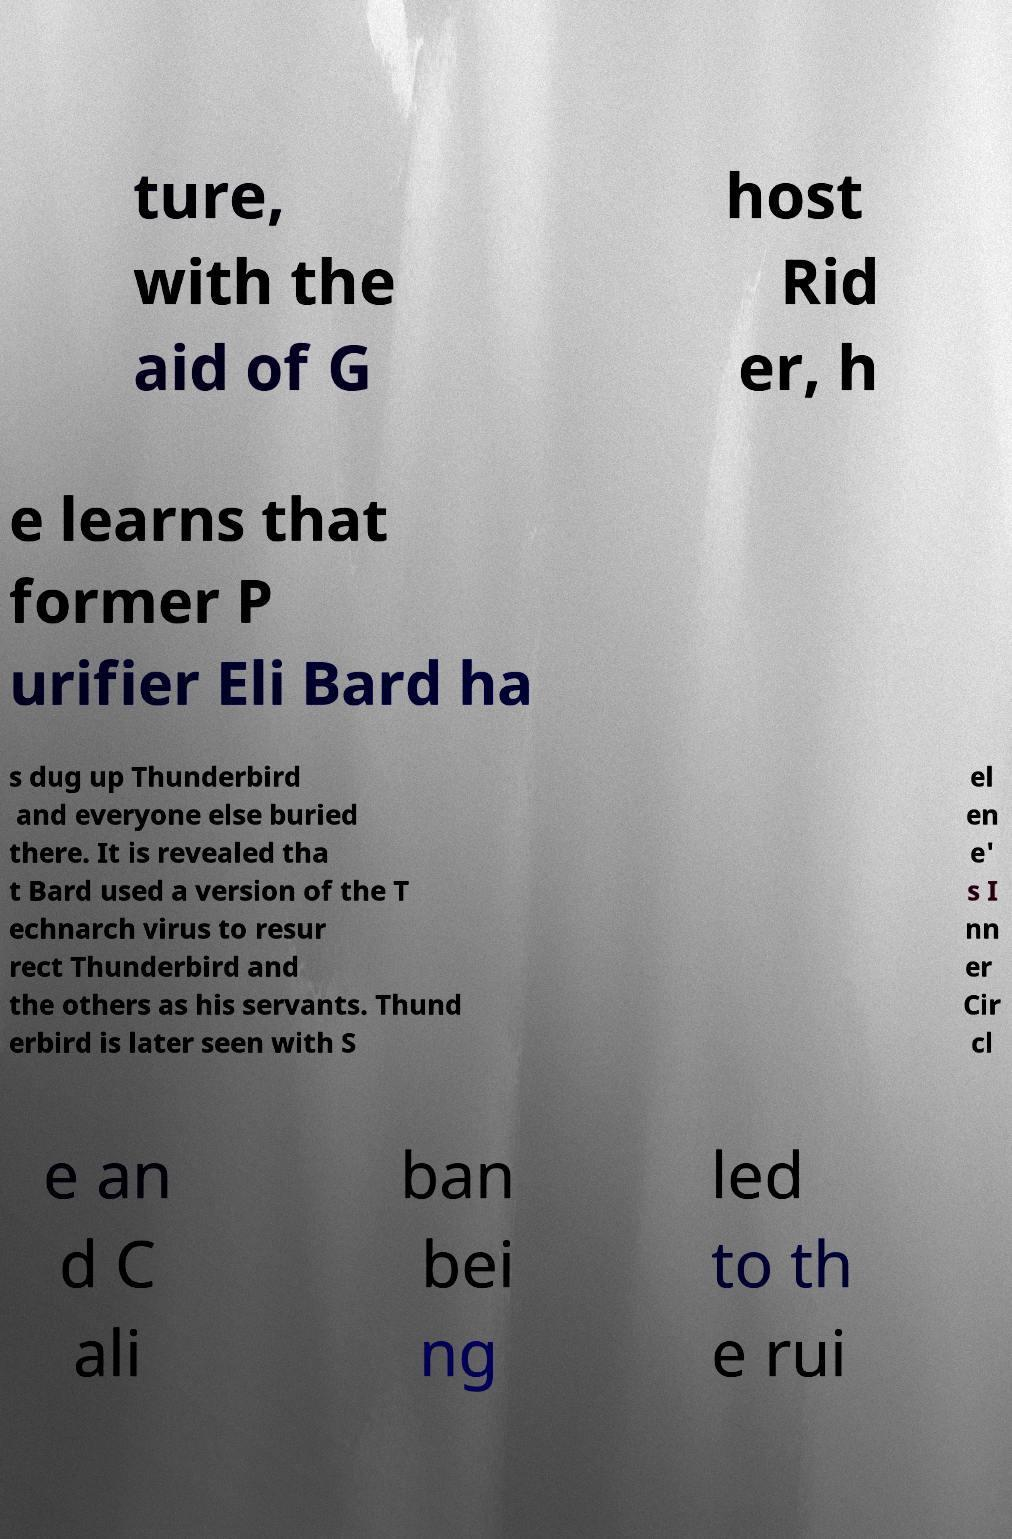For documentation purposes, I need the text within this image transcribed. Could you provide that? ture, with the aid of G host Rid er, h e learns that former P urifier Eli Bard ha s dug up Thunderbird and everyone else buried there. It is revealed tha t Bard used a version of the T echnarch virus to resur rect Thunderbird and the others as his servants. Thund erbird is later seen with S el en e' s I nn er Cir cl e an d C ali ban bei ng led to th e rui 